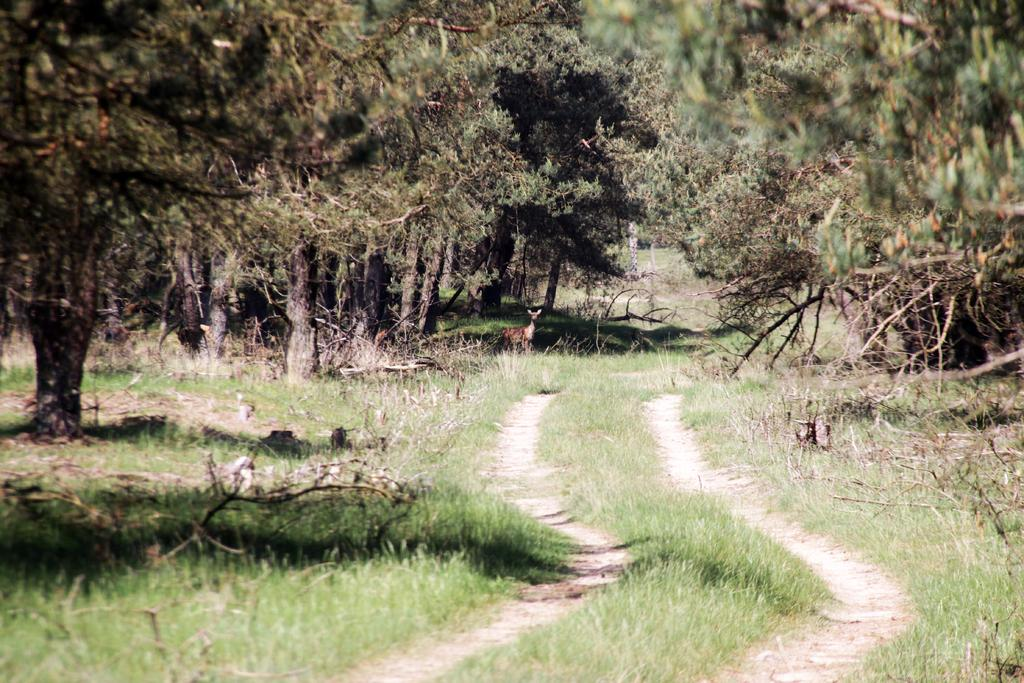What type of path is present in the image? There is a walkway in the image. What type of vegetation can be seen in the image? Grass is visible in the image. What can be seen in the background of the image? There are trees and deer in the background of the image. What type of prose is being recited by the deer in the image? There is no indication in the image that the deer are reciting any prose, as they are wild animals and not capable of human speech or actions. 